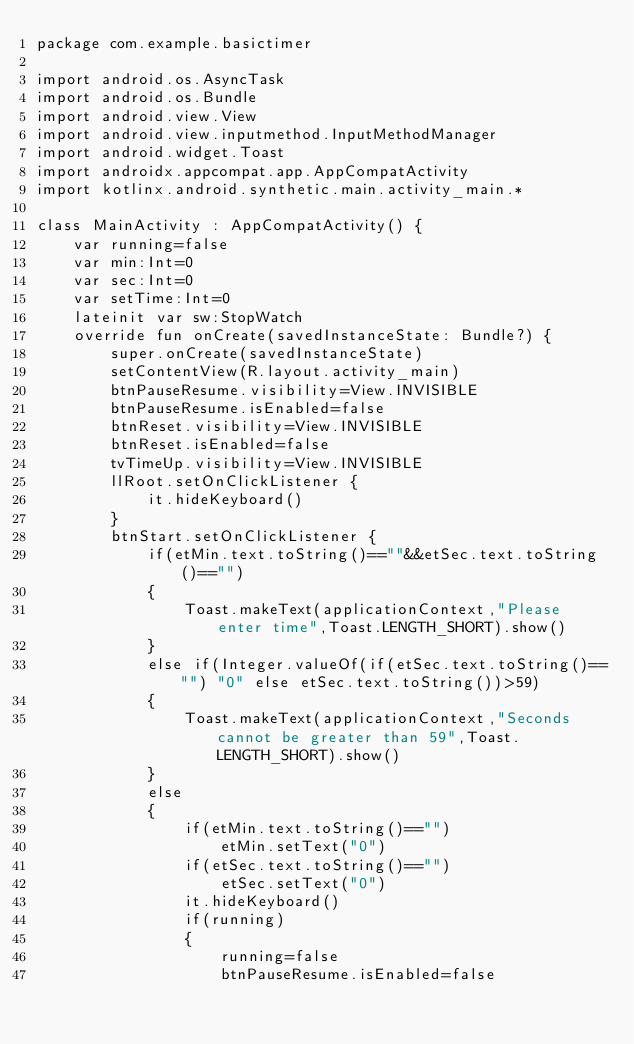<code> <loc_0><loc_0><loc_500><loc_500><_Kotlin_>package com.example.basictimer

import android.os.AsyncTask
import android.os.Bundle
import android.view.View
import android.view.inputmethod.InputMethodManager
import android.widget.Toast
import androidx.appcompat.app.AppCompatActivity
import kotlinx.android.synthetic.main.activity_main.*

class MainActivity : AppCompatActivity() {
    var running=false
    var min:Int=0
    var sec:Int=0
    var setTime:Int=0
    lateinit var sw:StopWatch
    override fun onCreate(savedInstanceState: Bundle?) {
        super.onCreate(savedInstanceState)
        setContentView(R.layout.activity_main)
        btnPauseResume.visibility=View.INVISIBLE
        btnPauseResume.isEnabled=false
        btnReset.visibility=View.INVISIBLE
        btnReset.isEnabled=false
        tvTimeUp.visibility=View.INVISIBLE
        llRoot.setOnClickListener {
            it.hideKeyboard()
        }
        btnStart.setOnClickListener {
            if(etMin.text.toString()==""&&etSec.text.toString()=="")
            {
                Toast.makeText(applicationContext,"Please enter time",Toast.LENGTH_SHORT).show()
            }
            else if(Integer.valueOf(if(etSec.text.toString()=="") "0" else etSec.text.toString())>59)
            {
                Toast.makeText(applicationContext,"Seconds cannot be greater than 59",Toast.LENGTH_SHORT).show()
            }
            else
            {
                if(etMin.text.toString()=="")
                    etMin.setText("0")
                if(etSec.text.toString()=="")
                    etSec.setText("0")
                it.hideKeyboard()
                if(running)
                {
                    running=false
                    btnPauseResume.isEnabled=false</code> 